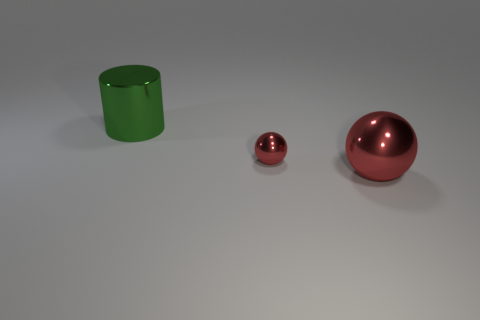There is a ball that is the same color as the small shiny object; what size is it?
Provide a short and direct response. Large. Is the material of the small red thing the same as the large thing right of the green metallic cylinder?
Your response must be concise. Yes. There is a object that is both in front of the large cylinder and left of the large red thing; what is it made of?
Give a very brief answer. Metal. There is a large thing that is on the left side of the red metal ball that is behind the large red thing; what is its color?
Make the answer very short. Green. There is a large object that is in front of the green thing; what material is it?
Give a very brief answer. Metal. Is the number of big gray matte objects less than the number of large shiny things?
Give a very brief answer. Yes. There is a large green metal object; does it have the same shape as the big metal object in front of the big metal cylinder?
Offer a very short reply. No. There is a metal thing that is both on the right side of the big cylinder and left of the large metallic sphere; what is its shape?
Your response must be concise. Sphere. Is the number of spheres that are in front of the tiny metallic thing the same as the number of metal objects on the right side of the big red object?
Offer a very short reply. No. Is the shape of the object to the right of the small shiny object the same as  the small red metallic object?
Offer a very short reply. Yes. 